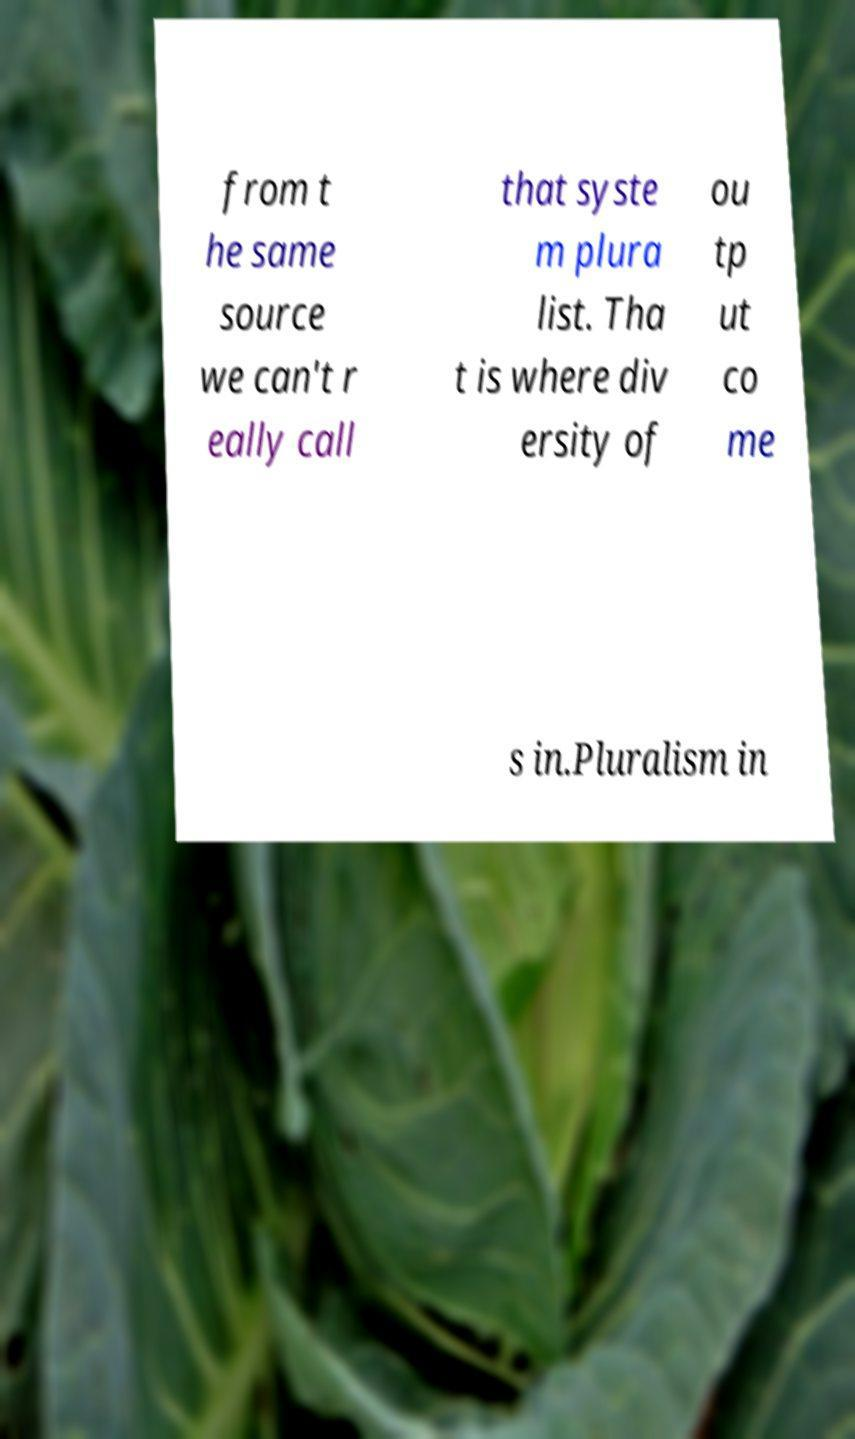Could you extract and type out the text from this image? from t he same source we can't r eally call that syste m plura list. Tha t is where div ersity of ou tp ut co me s in.Pluralism in 